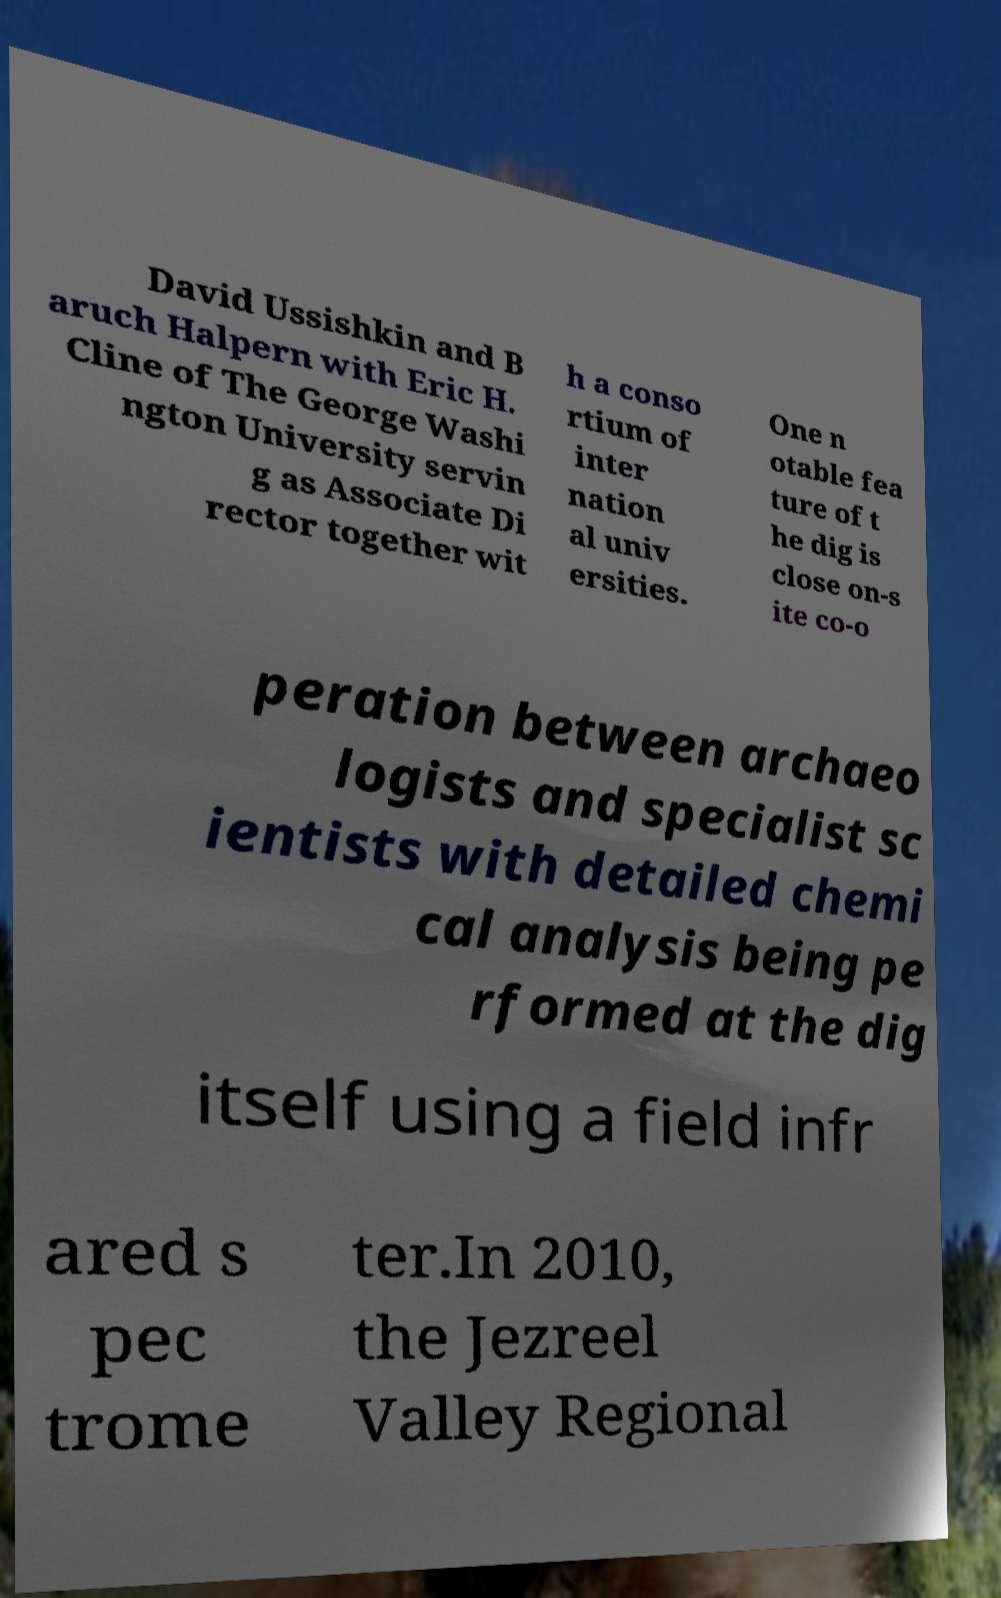Can you read and provide the text displayed in the image?This photo seems to have some interesting text. Can you extract and type it out for me? David Ussishkin and B aruch Halpern with Eric H. Cline of The George Washi ngton University servin g as Associate Di rector together wit h a conso rtium of inter nation al univ ersities. One n otable fea ture of t he dig is close on-s ite co-o peration between archaeo logists and specialist sc ientists with detailed chemi cal analysis being pe rformed at the dig itself using a field infr ared s pec trome ter.In 2010, the Jezreel Valley Regional 